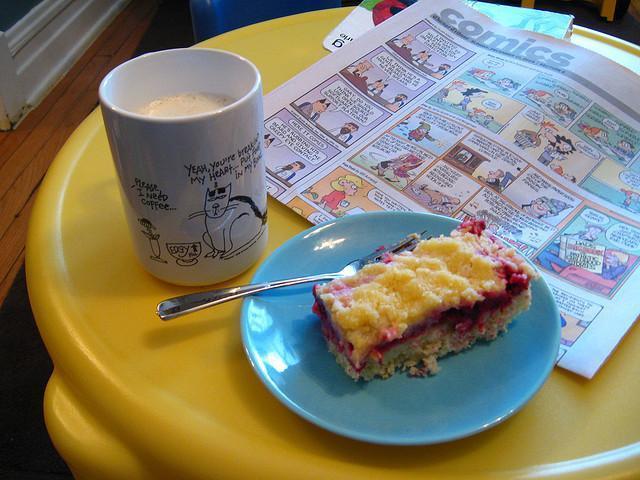How many cups are in the picture?
Give a very brief answer. 1. How many pieces of food are on the table?
Give a very brief answer. 1. How many cups are there?
Give a very brief answer. 1. 